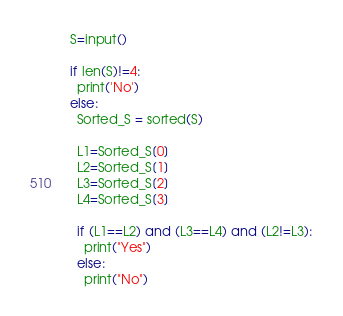Convert code to text. <code><loc_0><loc_0><loc_500><loc_500><_Python_>S=input()

if len(S)!=4:
  print('No')
else:  
  Sorted_S = sorted(S)
  
  L1=Sorted_S[0]
  L2=Sorted_S[1]
  L3=Sorted_S[2]
  L4=Sorted_S[3]

  if (L1==L2) and (L3==L4) and (L2!=L3):
    print("Yes")
  else:
    print("No")
</code> 